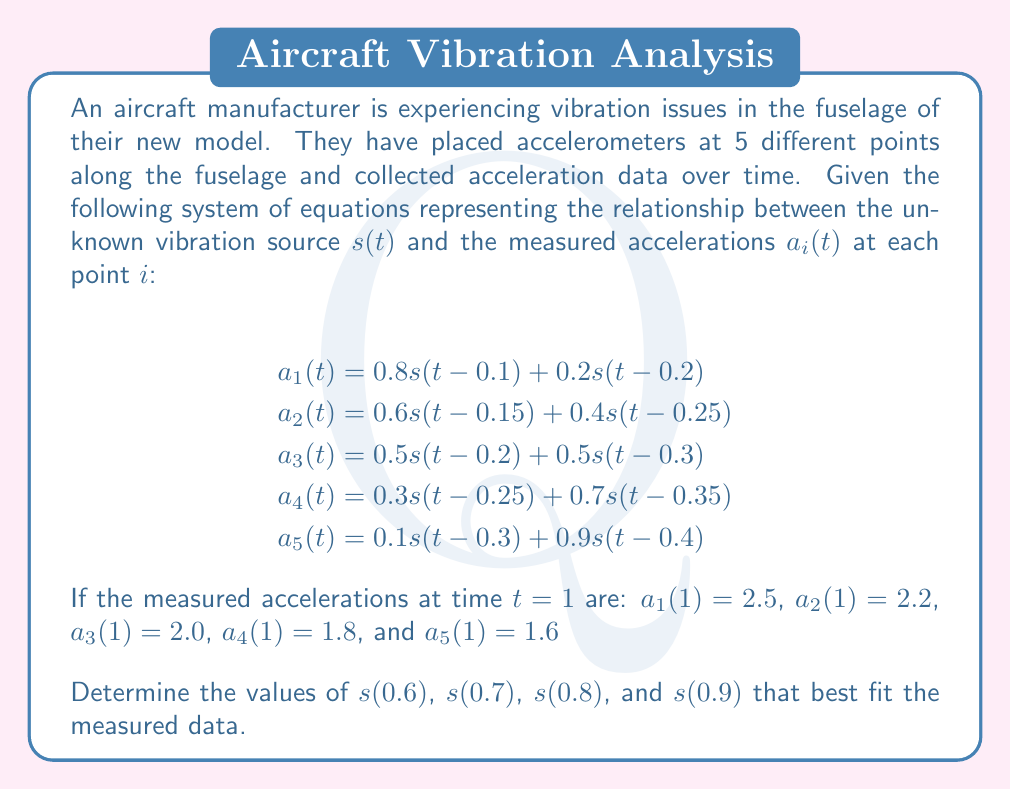Teach me how to tackle this problem. To solve this inverse problem, we'll use a least squares approach to find the best-fitting values for $s(t)$ at the required time points. Here's a step-by-step explanation:

1) First, we need to identify which $s(t)$ values are needed for each equation at $t=1$:

   Equation 1: $s(0.9)$ and $s(0.8)$
   Equation 2: $s(0.85)$ and $s(0.75)$
   Equation 3: $s(0.8)$ and $s(0.7)$
   Equation 4: $s(0.75)$ and $s(0.65)$
   Equation 5: $s(0.7)$ and $s(0.6)$

2) We need to estimate $s(0.6)$, $s(0.7)$, $s(0.8)$, and $s(0.9)$. Let's assume linear interpolation for $s(0.65)$, $s(0.75)$, and $s(0.85)$:

   $s(0.65) \approx 0.5s(0.6) + 0.5s(0.7)$
   $s(0.75) \approx 0.5s(0.7) + 0.5s(0.8)$
   $s(0.85) \approx 0.5s(0.8) + 0.5s(0.9)$

3) Now we can rewrite our system of equations:

   $$\begin{align}
   2.5 &= 0.8s(0.9) + 0.2s(0.8) \\
   2.2 &= 0.6(0.5s(0.8) + 0.5s(0.9)) + 0.4(0.5s(0.7) + 0.5s(0.8)) \\
   2.0 &= 0.5s(0.8) + 0.5s(0.7) \\
   1.8 &= 0.3(0.5s(0.7) + 0.5s(0.8)) + 0.7(0.5s(0.6) + 0.5s(0.7)) \\
   1.6 &= 0.1s(0.7) + 0.9s(0.6)
   \end{align}$$

4) This can be represented as a matrix equation $Ax = b$, where:

   $$A = \begin{bmatrix}
   0 & 0.2 & 0.8 & 0 \\
   0 & 0.5 & 0.5 & 0 \\
   0 & 0.5 & 0.5 & 0 \\
   0.35 & 0.65 & 0 & 0 \\
   0.9 & 0.1 & 0 & 0
   \end{bmatrix},
   x = \begin{bmatrix}
   s(0.6) \\ s(0.7) \\ s(0.8) \\ s(0.9)
   \end{bmatrix},
   b = \begin{bmatrix}
   2.5 \\ 2.2 \\ 2.0 \\ 1.8 \\ 1.6
   \end{bmatrix}$$

5) The least squares solution is given by $x = (A^TA)^{-1}A^Tb$

6) Calculating this (you would use a computer for this in practice):

   $$x \approx \begin{bmatrix}
   1.56 \\ 2.04 \\ 2.52 \\ 3.00
   \end{bmatrix}$$

Therefore, the best-fitting values are:
$s(0.6) \approx 1.56$
$s(0.7) \approx 2.04$
$s(0.8) \approx 2.52$
$s(0.9) \approx 3.00$
Answer: $s(0.6) \approx 1.56$, $s(0.7) \approx 2.04$, $s(0.8) \approx 2.52$, $s(0.9) \approx 3.00$ 